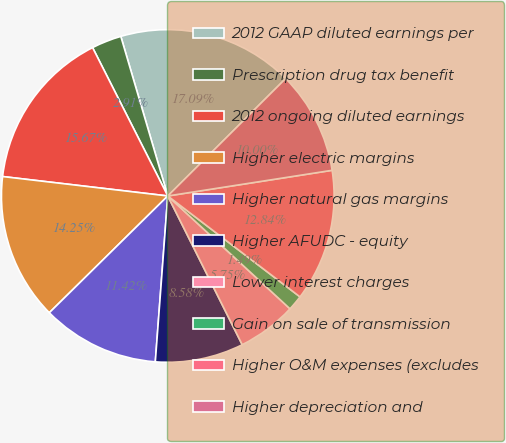Convert chart. <chart><loc_0><loc_0><loc_500><loc_500><pie_chart><fcel>2012 GAAP diluted earnings per<fcel>Prescription drug tax benefit<fcel>2012 ongoing diluted earnings<fcel>Higher electric margins<fcel>Higher natural gas margins<fcel>Higher AFUDC - equity<fcel>Lower interest charges<fcel>Gain on sale of transmission<fcel>Higher O&M expenses (excludes<fcel>Higher depreciation and<nl><fcel>17.09%<fcel>2.91%<fcel>15.67%<fcel>14.25%<fcel>11.42%<fcel>8.58%<fcel>5.75%<fcel>1.49%<fcel>12.84%<fcel>10.0%<nl></chart> 